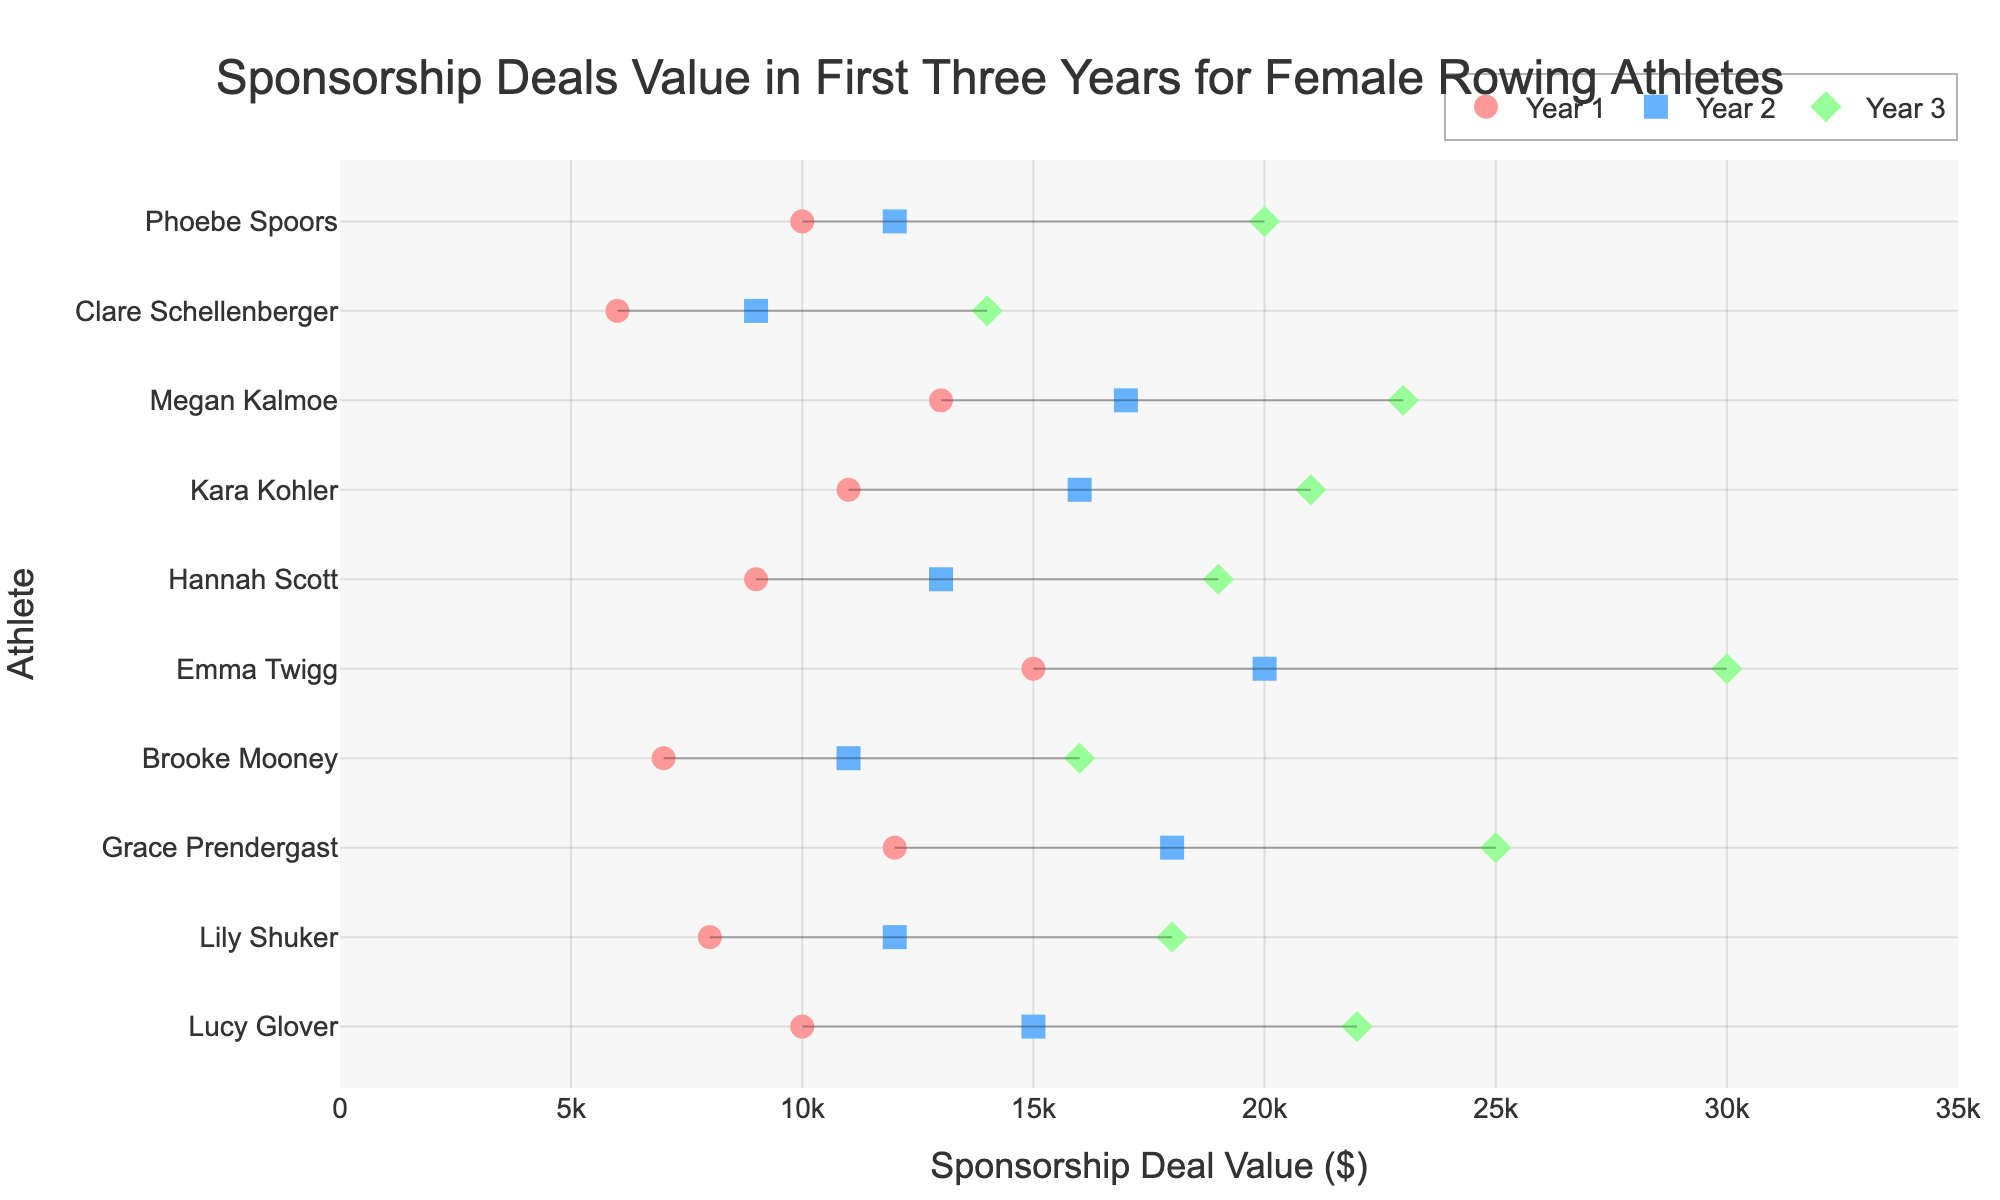which athlete has the highest sponsorship deal value in year 3? The dot representing Year 3 sponsorship values for each athlete has the highest value for Emma Twigg.
Answer: Emma Twigg what is the difference in sponsorship deal value between year 1 and year 3 for Lucy Glover? Lucy Glover has a Year 1 value of $10,000 and a Year 3 value of $22,000. The difference is $22,000 - $10,000.
Answer: $12,000 which athletes have a sponsorship deal value lower than $10,000 in year 1? The Year 1 dots that are less than $10,000 belong to Brooke Mooney and Clare Schellenberger.
Answer: Brooke Mooney, Clare Schellenberger what is the average sponsorship deal value in year 2 for all athletes? Sum the Year 2 values for all athletes and divide by the number of athletes: (15000 + 12000 + 18000 + 11000 + 20000 + 13000 + 16000 + 17000 + 9000 + 12000) / 10.
Answer: $14,700 which athlete shows the greatest increase in sponsorship deal value from year 1 to year 3? Calculate the increase for each athlete from Year 1 to Year 3 and find the maximum. Emma Twigg increases from $15,000 to $30,000, which is the largest increase.
Answer: Emma Twigg how many athletes have a sponsorship deal value of at least $20,000 in year 3? Count the number of Year 3 dots that are $20,000 or higher. There are five such values.
Answer: 5 which athlete's sponsorship deal value remained below $15,000 in all three years? Clare Schellenberger's values remain below $15,000 for Year 1, Year 2, and Year 3.
Answer: Clare Schellenberger what is the total sponsorship deal value of Grace Prendergast over the three years? Sum Grace Prendergast's values for Year 1, Year 2, and Year 3: $12,000 + $18,000 + $25,000.
Answer: $55,000 how does Megan Kalmoe's sponsorship deal value in year 2 compare to Emma Twigg's in the same year? Megan Kalmoe's Year 2 value is $17,000, and Emma Twigg's Year 2 value is $20,000. Megan Kalmoe's value is less than Emma Twigg's.
Answer: less than 